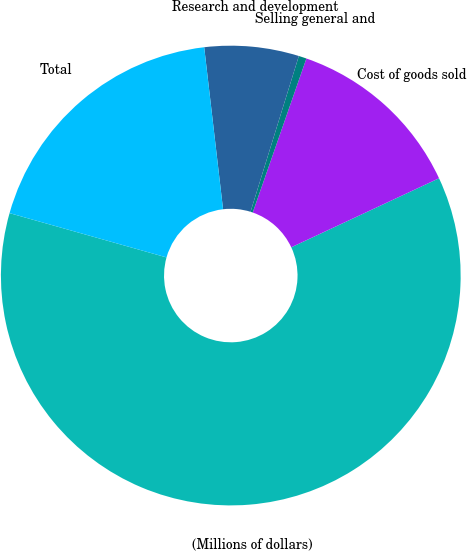<chart> <loc_0><loc_0><loc_500><loc_500><pie_chart><fcel>(Millions of dollars)<fcel>Cost of goods sold<fcel>Selling general and<fcel>Research and development<fcel>Total<nl><fcel>61.34%<fcel>12.71%<fcel>0.55%<fcel>6.63%<fcel>18.78%<nl></chart> 